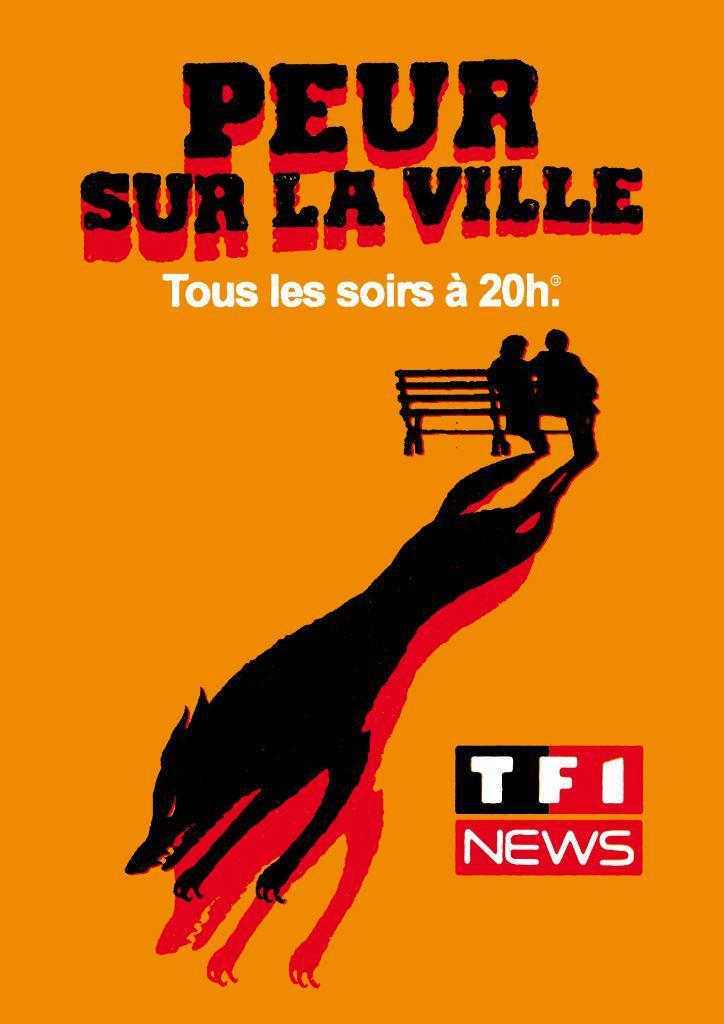In one or two sentences, can you explain what this image depicts? In this picture we can see a poster and on the poster there are two people sitting on a bench. 